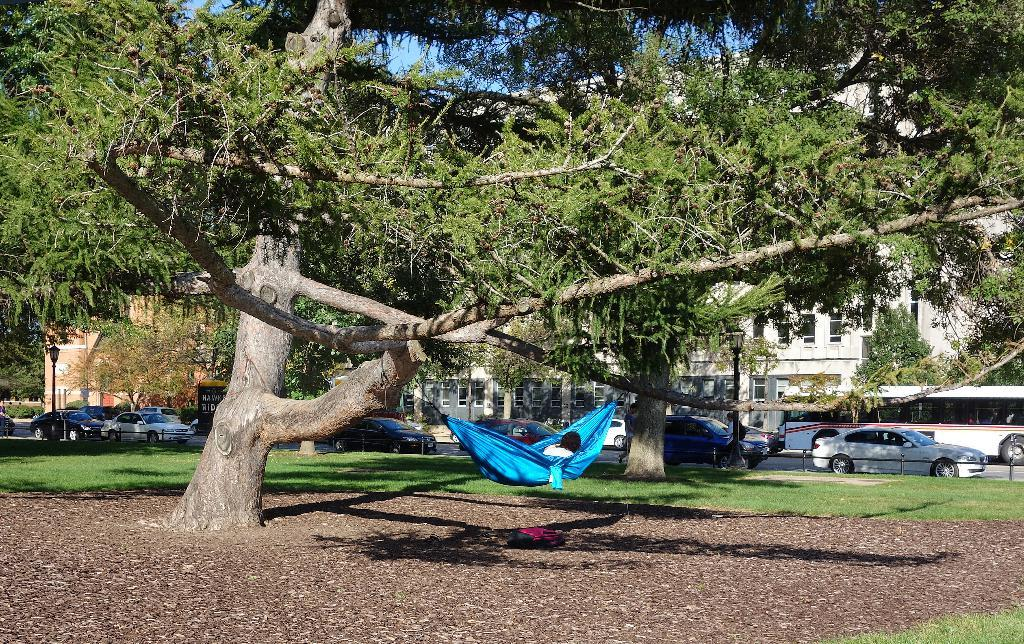What type of vegetation can be seen in the image? There is grass in the image. What else can be seen in the image besides the grass? There are vehicles, poles, lights, trees, buildings, and a person lying on a hammock visible in the image. What is the purpose of the poles in the image? The poles are likely supporting the lights in the image. What is the person lying on in the image? The person is lying on a hammock. What is visible in the background of the image? The sky is visible in the background of the image. Where can the icicle be found in the image? There is no icicle present in the image. What type of stick is being used by the person lying on the hammock? There is no stick visible in the image, and the person lying on the hammock is not using any object. 